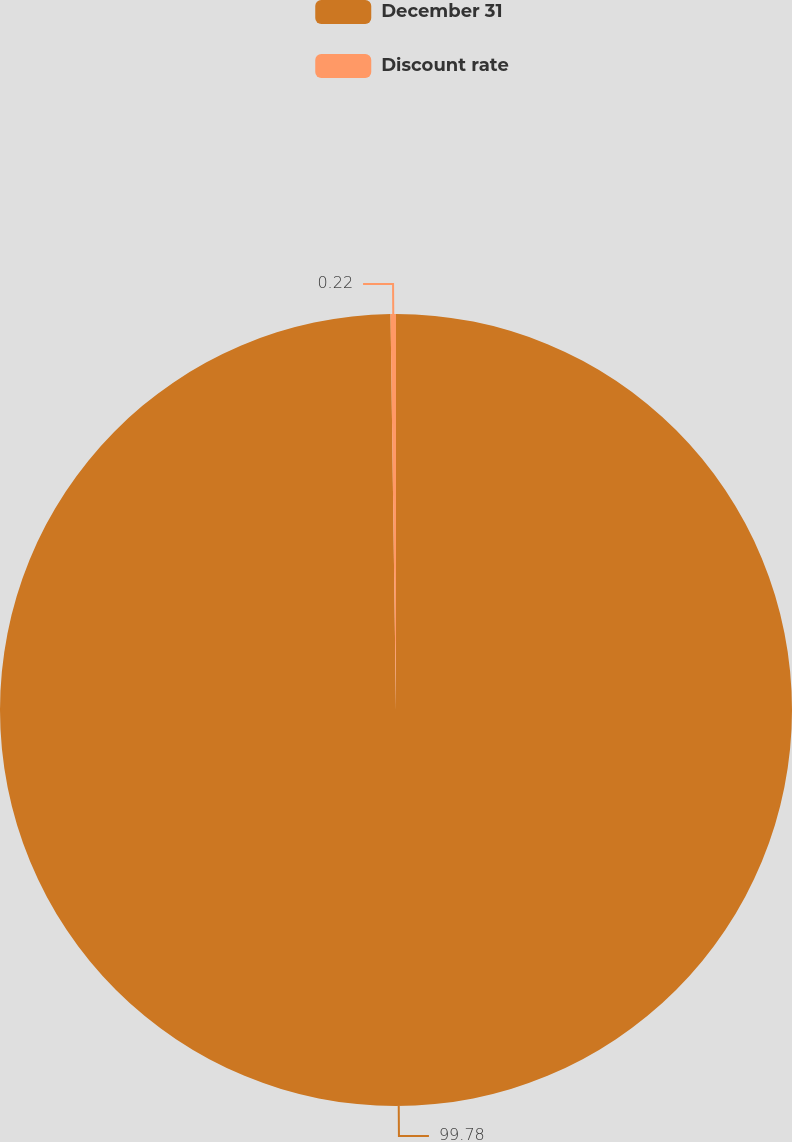Convert chart to OTSL. <chart><loc_0><loc_0><loc_500><loc_500><pie_chart><fcel>December 31<fcel>Discount rate<nl><fcel>99.78%<fcel>0.22%<nl></chart> 